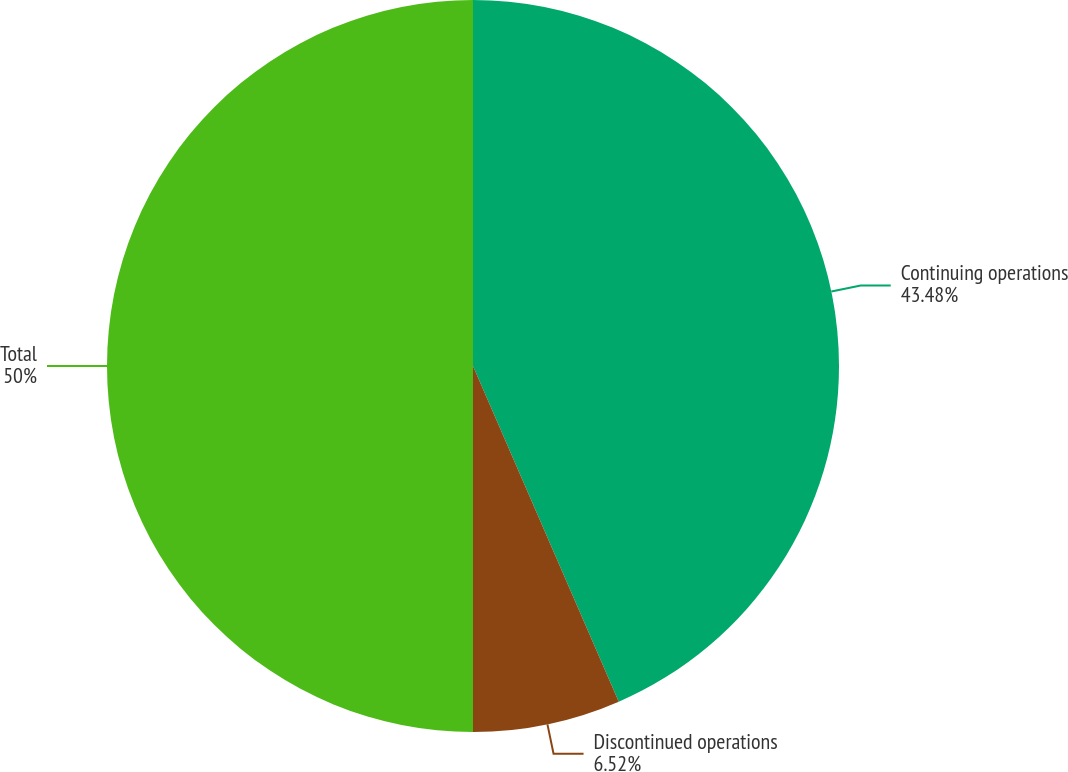<chart> <loc_0><loc_0><loc_500><loc_500><pie_chart><fcel>Continuing operations<fcel>Discontinued operations<fcel>Total<nl><fcel>43.48%<fcel>6.52%<fcel>50.0%<nl></chart> 